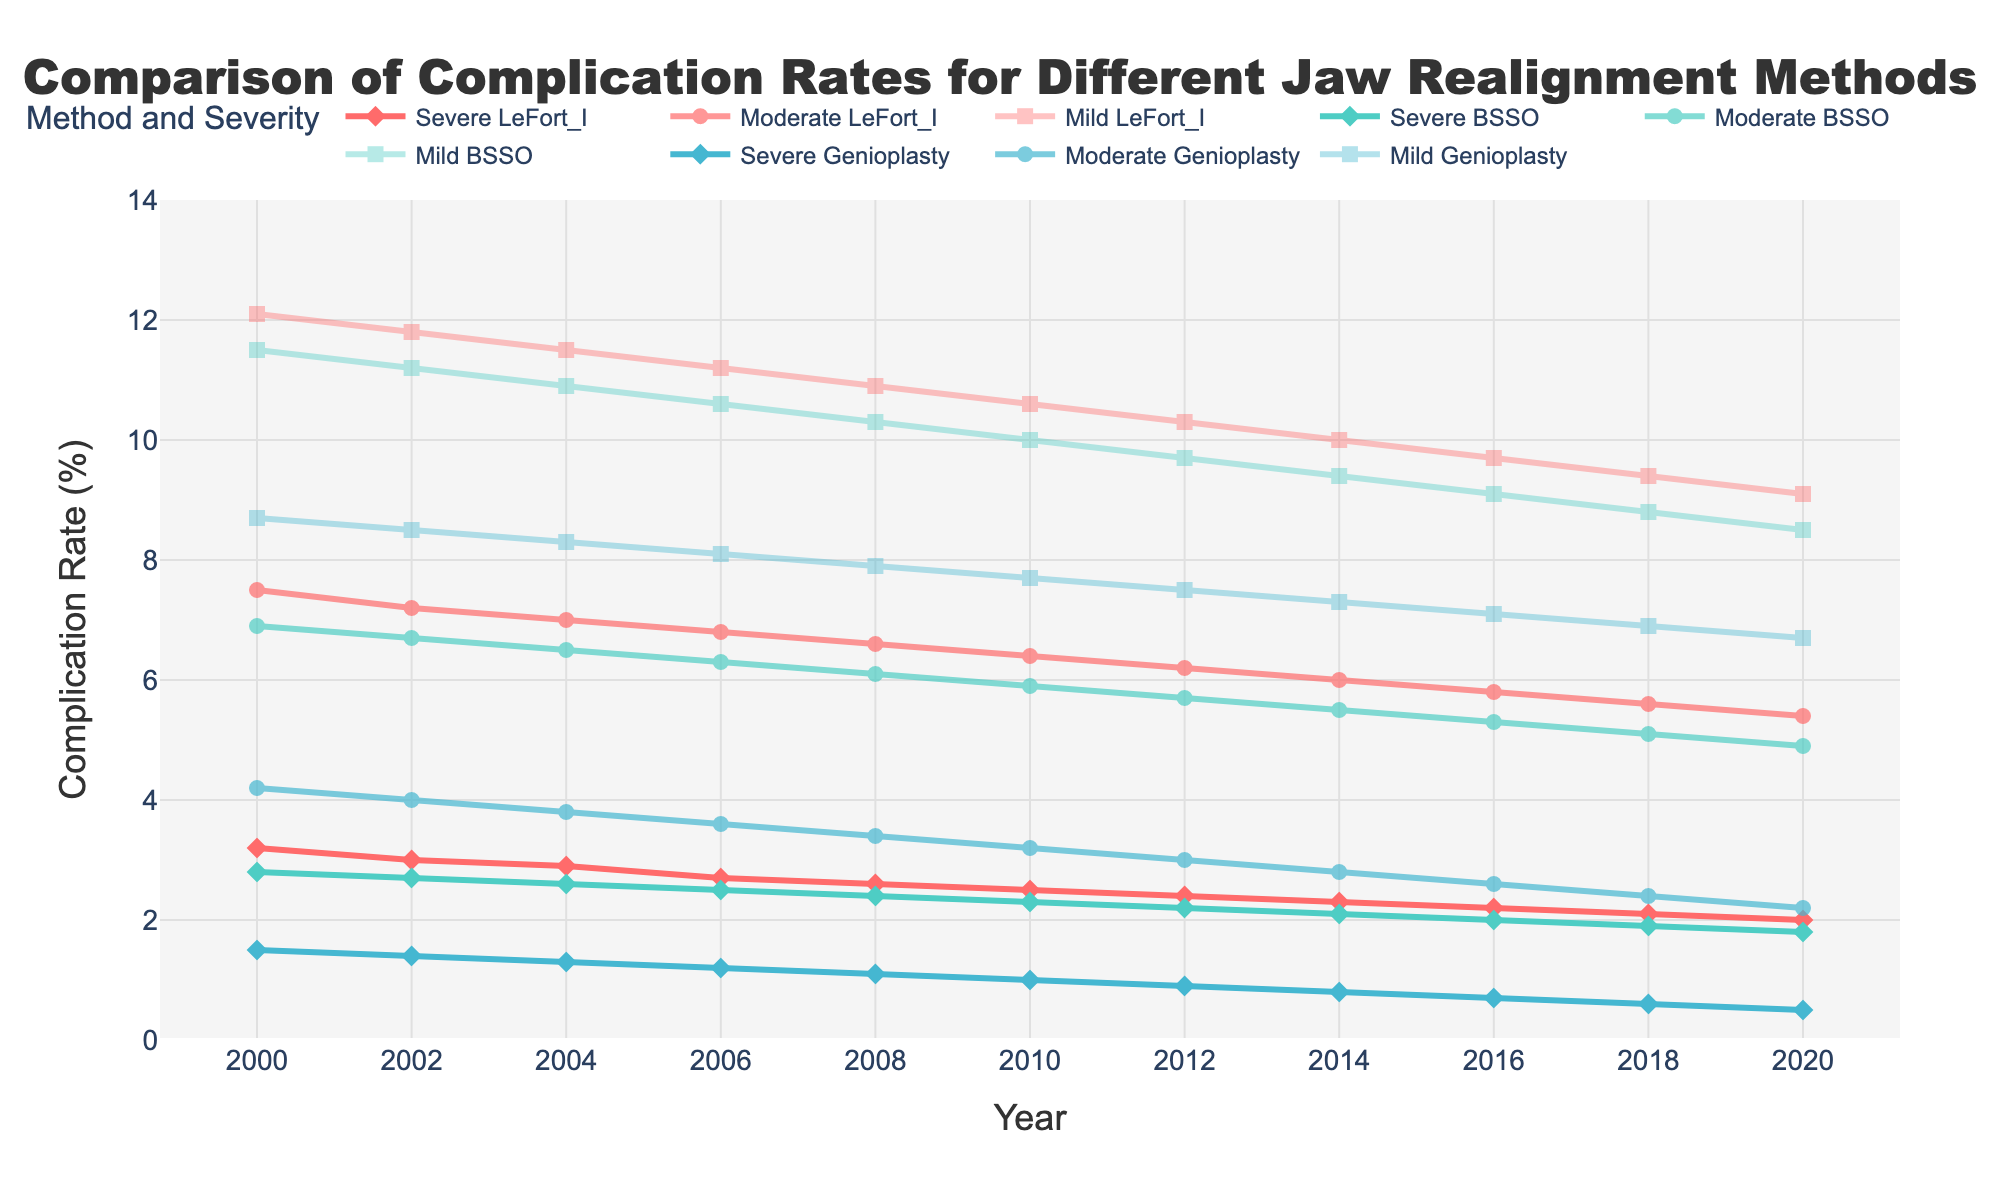which jaw realignment method had the highest severe complication rate in 2000? Look under the Severe column for each method (LeFort I, BSSO, Genioplasty) for the year 2000. LeFort I had 3.2%, BSSO had 2.8%, and Genioplasty had 1.5%. Thus, LeFort I had the highest severe complication rate in 2000
Answer: LeFort I how did the mild complication rate for BSSO change from 2000 to 2020? Look at the Mild_BSSO column in 2000, which is 11.5%, and in 2020, which is 8.5%. Calculate the difference: 11.5% - 8.5% = 3% decrease
Answer: Decreased by 3% which year showed the lowest moderate complication rate for Genioplasty? Look through the Moderate_Genioplasty column to find the minimum value. The lowest value is in 2020 with a rate of 2.2%
Answer: 2020 how did the complication rates for severe, moderate, and mild LeFort I procedures trend over time? Observe the lines associated with Severe, Moderate, and Mild LeFort I. All three lines show a decreasing trend from 2000 to 2020
Answer: Decreasing trend compare the complication rates between BSSO and Genioplasty in 2010 for mild severity. Which one had a higher rate? In 2010, the Mild_BSSO rate was 10%, and the Mild_Genioplasty rate was 7.7%. BSSO had a higher rate
Answer: BSSO calculate the average severe complication rate across all methods in 2000 Add up the severe complication rates for LeFort I, BSSO, and Genioplasty in 2000: 3.2% + 2.8% + 1.5% = 7.5%. Divide this by 3 methods to get the average: 7.5% / 3 = 2.5%
Answer: 2.5% which procedure and severity level showed the greatest reduction in complication rate from 2000 to 2020? Calculate the difference for all procedure and severity combinations: 
- Severe LeFort I: 3.2% - 2.0% = 1.2%
- Moderate LeFort I: 7.5% - 5.4% = 2.1%
- Mild LeFort I: 12.1% - 9.1% = 3%
- Severe BSSO: 2.8% - 1.8% = 1%
- Moderate BSSO: 6.9% - 4.9% = 2%
- Mild BSSO: 11.5% - 8.5% = 3%
- Severe Genioplasty: 1.5% - 0.5% = 1%
- Moderate Genioplasty: 4.2% - 2.2% = 2%
- Mild Genioplasty: 8.7% - 6.7% = 2%
The greatest reduction is 3% for both Mild LeFort I and Mild BSSO
Answer: Mild LeFort I and Mild BSSO what visual characteristic distinguishes the severe, moderate, and mild categories in the plot? The severe lines use diamond markers and are most opaque, moderate lines use circle markers and are less opaque, and mild lines use square markers and are the least opaque
Answer: Marker shape and opacity 